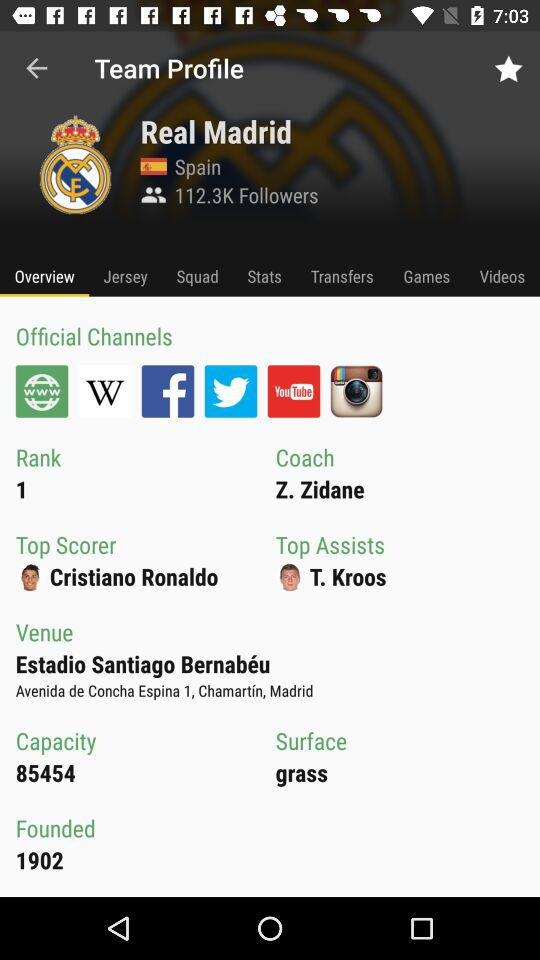What is the name of the coach? The name of the coach is Z. Zidane. 